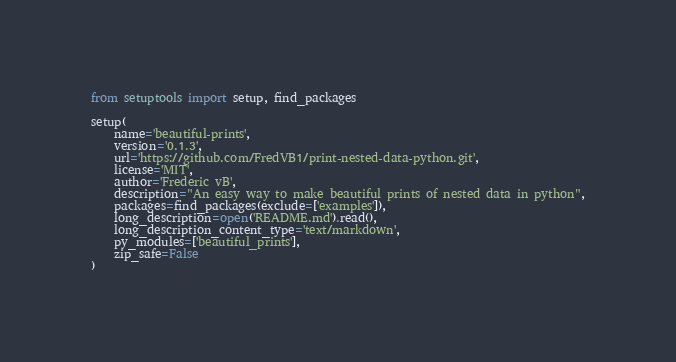<code> <loc_0><loc_0><loc_500><loc_500><_Python_>from setuptools import setup, find_packages

setup(
    name='beautiful-prints',
    version='0.1.3',
    url='https://github.com/FredVB1/print-nested-data-python.git',
    license='MIT',
    author='Frederic vB',
    description="An easy way to make beautiful prints of nested data in python",
    packages=find_packages(exclude=['examples']),
    long_description=open('README.md').read(),
    long_description_content_type='text/markdown',
    py_modules=['beautiful_prints'],
    zip_safe=False
)
</code> 